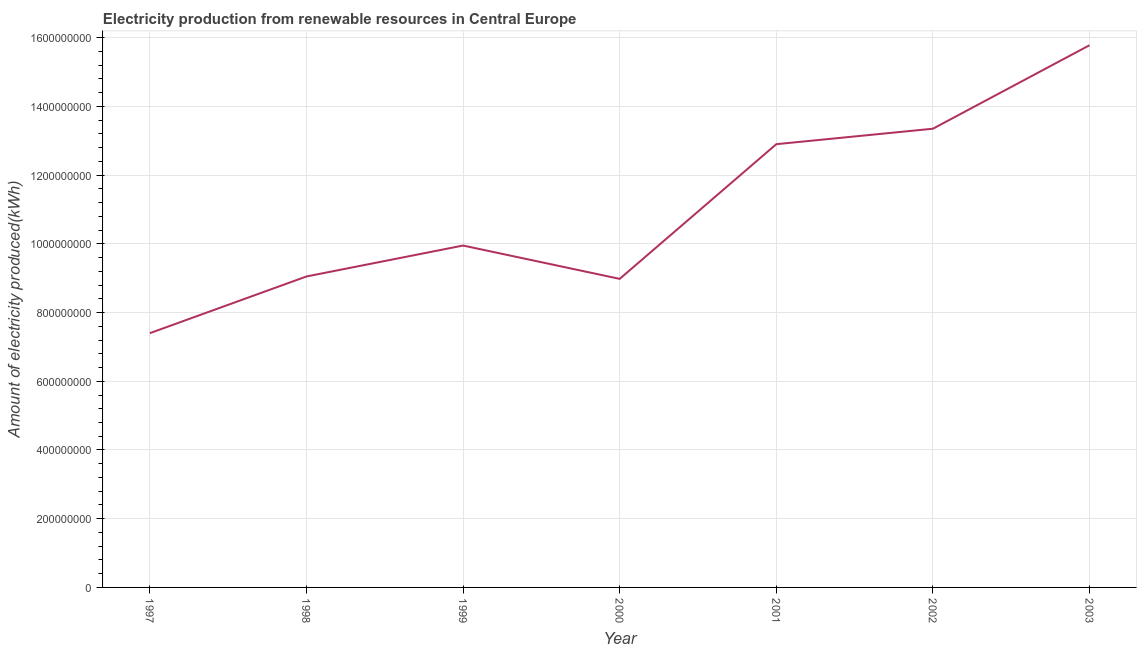What is the amount of electricity produced in 2001?
Offer a terse response. 1.29e+09. Across all years, what is the maximum amount of electricity produced?
Offer a terse response. 1.58e+09. Across all years, what is the minimum amount of electricity produced?
Make the answer very short. 7.40e+08. In which year was the amount of electricity produced maximum?
Offer a terse response. 2003. In which year was the amount of electricity produced minimum?
Your answer should be very brief. 1997. What is the sum of the amount of electricity produced?
Your answer should be very brief. 7.74e+09. What is the difference between the amount of electricity produced in 1998 and 2001?
Offer a very short reply. -3.85e+08. What is the average amount of electricity produced per year?
Your answer should be compact. 1.11e+09. What is the median amount of electricity produced?
Your response must be concise. 9.95e+08. In how many years, is the amount of electricity produced greater than 80000000 kWh?
Make the answer very short. 7. Do a majority of the years between 2000 and 2002 (inclusive) have amount of electricity produced greater than 1040000000 kWh?
Ensure brevity in your answer.  Yes. What is the ratio of the amount of electricity produced in 1998 to that in 2000?
Give a very brief answer. 1.01. Is the amount of electricity produced in 1999 less than that in 2000?
Offer a terse response. No. What is the difference between the highest and the second highest amount of electricity produced?
Your answer should be very brief. 2.43e+08. What is the difference between the highest and the lowest amount of electricity produced?
Ensure brevity in your answer.  8.38e+08. In how many years, is the amount of electricity produced greater than the average amount of electricity produced taken over all years?
Provide a succinct answer. 3. What is the title of the graph?
Your response must be concise. Electricity production from renewable resources in Central Europe. What is the label or title of the Y-axis?
Offer a very short reply. Amount of electricity produced(kWh). What is the Amount of electricity produced(kWh) in 1997?
Offer a terse response. 7.40e+08. What is the Amount of electricity produced(kWh) of 1998?
Your answer should be very brief. 9.05e+08. What is the Amount of electricity produced(kWh) in 1999?
Keep it short and to the point. 9.95e+08. What is the Amount of electricity produced(kWh) of 2000?
Your answer should be compact. 8.98e+08. What is the Amount of electricity produced(kWh) in 2001?
Keep it short and to the point. 1.29e+09. What is the Amount of electricity produced(kWh) of 2002?
Offer a terse response. 1.34e+09. What is the Amount of electricity produced(kWh) of 2003?
Ensure brevity in your answer.  1.58e+09. What is the difference between the Amount of electricity produced(kWh) in 1997 and 1998?
Keep it short and to the point. -1.65e+08. What is the difference between the Amount of electricity produced(kWh) in 1997 and 1999?
Your answer should be very brief. -2.55e+08. What is the difference between the Amount of electricity produced(kWh) in 1997 and 2000?
Keep it short and to the point. -1.58e+08. What is the difference between the Amount of electricity produced(kWh) in 1997 and 2001?
Your answer should be very brief. -5.50e+08. What is the difference between the Amount of electricity produced(kWh) in 1997 and 2002?
Offer a terse response. -5.95e+08. What is the difference between the Amount of electricity produced(kWh) in 1997 and 2003?
Offer a terse response. -8.38e+08. What is the difference between the Amount of electricity produced(kWh) in 1998 and 1999?
Your response must be concise. -9.00e+07. What is the difference between the Amount of electricity produced(kWh) in 1998 and 2001?
Your response must be concise. -3.85e+08. What is the difference between the Amount of electricity produced(kWh) in 1998 and 2002?
Your answer should be compact. -4.30e+08. What is the difference between the Amount of electricity produced(kWh) in 1998 and 2003?
Keep it short and to the point. -6.73e+08. What is the difference between the Amount of electricity produced(kWh) in 1999 and 2000?
Your response must be concise. 9.70e+07. What is the difference between the Amount of electricity produced(kWh) in 1999 and 2001?
Your answer should be very brief. -2.95e+08. What is the difference between the Amount of electricity produced(kWh) in 1999 and 2002?
Keep it short and to the point. -3.40e+08. What is the difference between the Amount of electricity produced(kWh) in 1999 and 2003?
Provide a succinct answer. -5.83e+08. What is the difference between the Amount of electricity produced(kWh) in 2000 and 2001?
Your response must be concise. -3.92e+08. What is the difference between the Amount of electricity produced(kWh) in 2000 and 2002?
Your answer should be compact. -4.37e+08. What is the difference between the Amount of electricity produced(kWh) in 2000 and 2003?
Give a very brief answer. -6.80e+08. What is the difference between the Amount of electricity produced(kWh) in 2001 and 2002?
Give a very brief answer. -4.50e+07. What is the difference between the Amount of electricity produced(kWh) in 2001 and 2003?
Provide a succinct answer. -2.88e+08. What is the difference between the Amount of electricity produced(kWh) in 2002 and 2003?
Provide a succinct answer. -2.43e+08. What is the ratio of the Amount of electricity produced(kWh) in 1997 to that in 1998?
Keep it short and to the point. 0.82. What is the ratio of the Amount of electricity produced(kWh) in 1997 to that in 1999?
Your answer should be very brief. 0.74. What is the ratio of the Amount of electricity produced(kWh) in 1997 to that in 2000?
Your answer should be compact. 0.82. What is the ratio of the Amount of electricity produced(kWh) in 1997 to that in 2001?
Offer a very short reply. 0.57. What is the ratio of the Amount of electricity produced(kWh) in 1997 to that in 2002?
Give a very brief answer. 0.55. What is the ratio of the Amount of electricity produced(kWh) in 1997 to that in 2003?
Your response must be concise. 0.47. What is the ratio of the Amount of electricity produced(kWh) in 1998 to that in 1999?
Make the answer very short. 0.91. What is the ratio of the Amount of electricity produced(kWh) in 1998 to that in 2001?
Provide a short and direct response. 0.7. What is the ratio of the Amount of electricity produced(kWh) in 1998 to that in 2002?
Ensure brevity in your answer.  0.68. What is the ratio of the Amount of electricity produced(kWh) in 1998 to that in 2003?
Give a very brief answer. 0.57. What is the ratio of the Amount of electricity produced(kWh) in 1999 to that in 2000?
Ensure brevity in your answer.  1.11. What is the ratio of the Amount of electricity produced(kWh) in 1999 to that in 2001?
Your answer should be very brief. 0.77. What is the ratio of the Amount of electricity produced(kWh) in 1999 to that in 2002?
Your answer should be compact. 0.74. What is the ratio of the Amount of electricity produced(kWh) in 1999 to that in 2003?
Make the answer very short. 0.63. What is the ratio of the Amount of electricity produced(kWh) in 2000 to that in 2001?
Provide a short and direct response. 0.7. What is the ratio of the Amount of electricity produced(kWh) in 2000 to that in 2002?
Ensure brevity in your answer.  0.67. What is the ratio of the Amount of electricity produced(kWh) in 2000 to that in 2003?
Make the answer very short. 0.57. What is the ratio of the Amount of electricity produced(kWh) in 2001 to that in 2002?
Your response must be concise. 0.97. What is the ratio of the Amount of electricity produced(kWh) in 2001 to that in 2003?
Offer a very short reply. 0.82. What is the ratio of the Amount of electricity produced(kWh) in 2002 to that in 2003?
Your answer should be very brief. 0.85. 